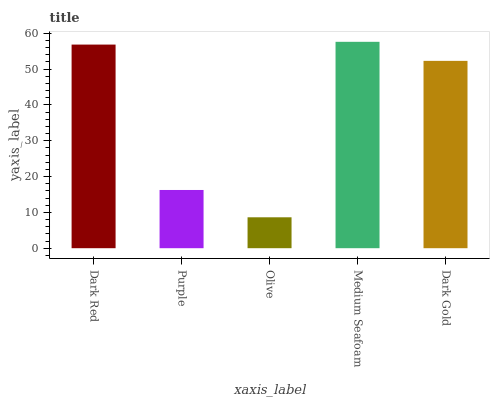Is Olive the minimum?
Answer yes or no. Yes. Is Medium Seafoam the maximum?
Answer yes or no. Yes. Is Purple the minimum?
Answer yes or no. No. Is Purple the maximum?
Answer yes or no. No. Is Dark Red greater than Purple?
Answer yes or no. Yes. Is Purple less than Dark Red?
Answer yes or no. Yes. Is Purple greater than Dark Red?
Answer yes or no. No. Is Dark Red less than Purple?
Answer yes or no. No. Is Dark Gold the high median?
Answer yes or no. Yes. Is Dark Gold the low median?
Answer yes or no. Yes. Is Dark Red the high median?
Answer yes or no. No. Is Purple the low median?
Answer yes or no. No. 